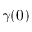<formula> <loc_0><loc_0><loc_500><loc_500>\gamma ( 0 )</formula> 